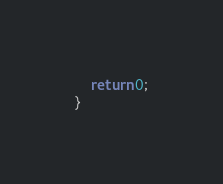Convert code to text. <code><loc_0><loc_0><loc_500><loc_500><_C++_>
    return 0;
}
</code> 